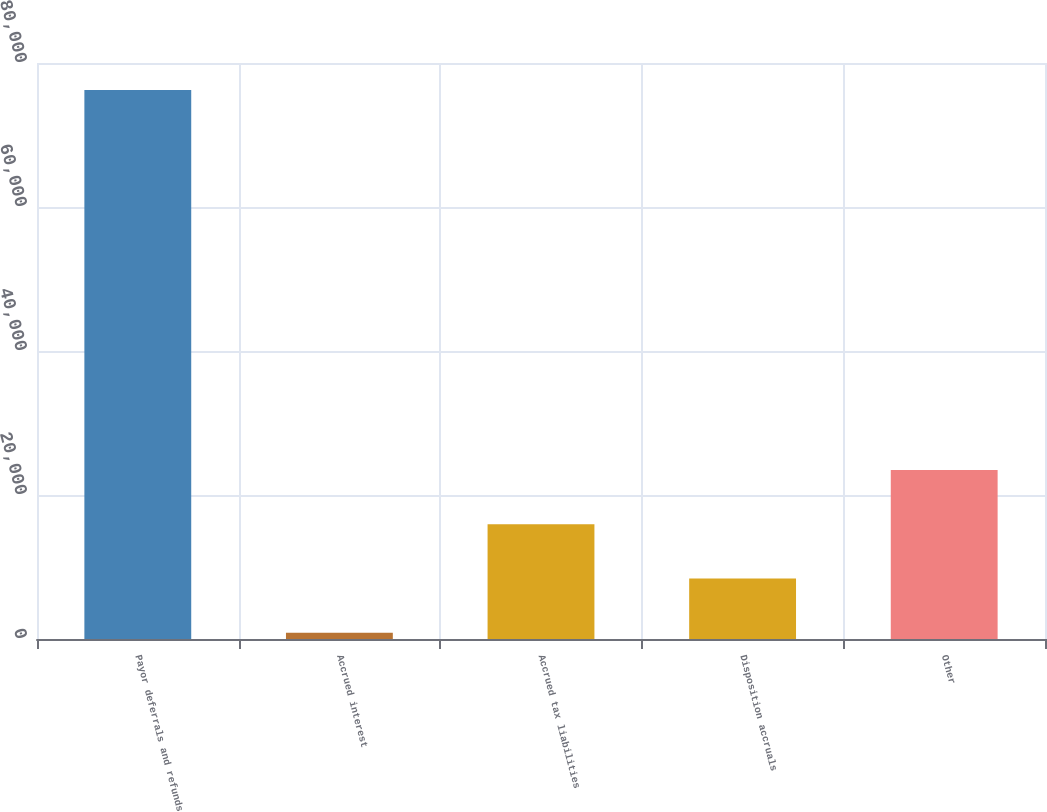Convert chart. <chart><loc_0><loc_0><loc_500><loc_500><bar_chart><fcel>Payor deferrals and refunds<fcel>Accrued interest<fcel>Accrued tax liabilities<fcel>Disposition accruals<fcel>Other<nl><fcel>76235<fcel>878<fcel>15949.4<fcel>8413.7<fcel>23485.1<nl></chart> 